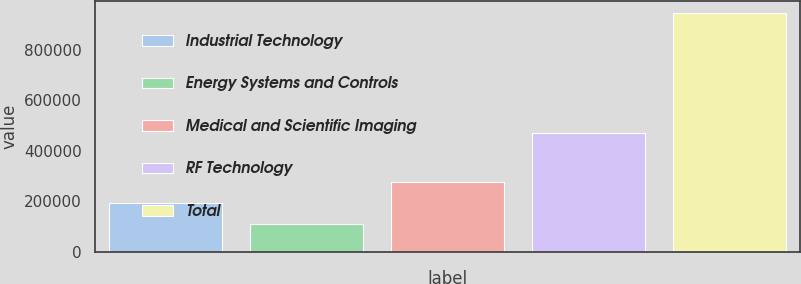Convert chart to OTSL. <chart><loc_0><loc_0><loc_500><loc_500><bar_chart><fcel>Industrial Technology<fcel>Energy Systems and Controls<fcel>Medical and Scientific Imaging<fcel>RF Technology<fcel>Total<nl><fcel>193618<fcel>109885<fcel>277351<fcel>471185<fcel>947217<nl></chart> 